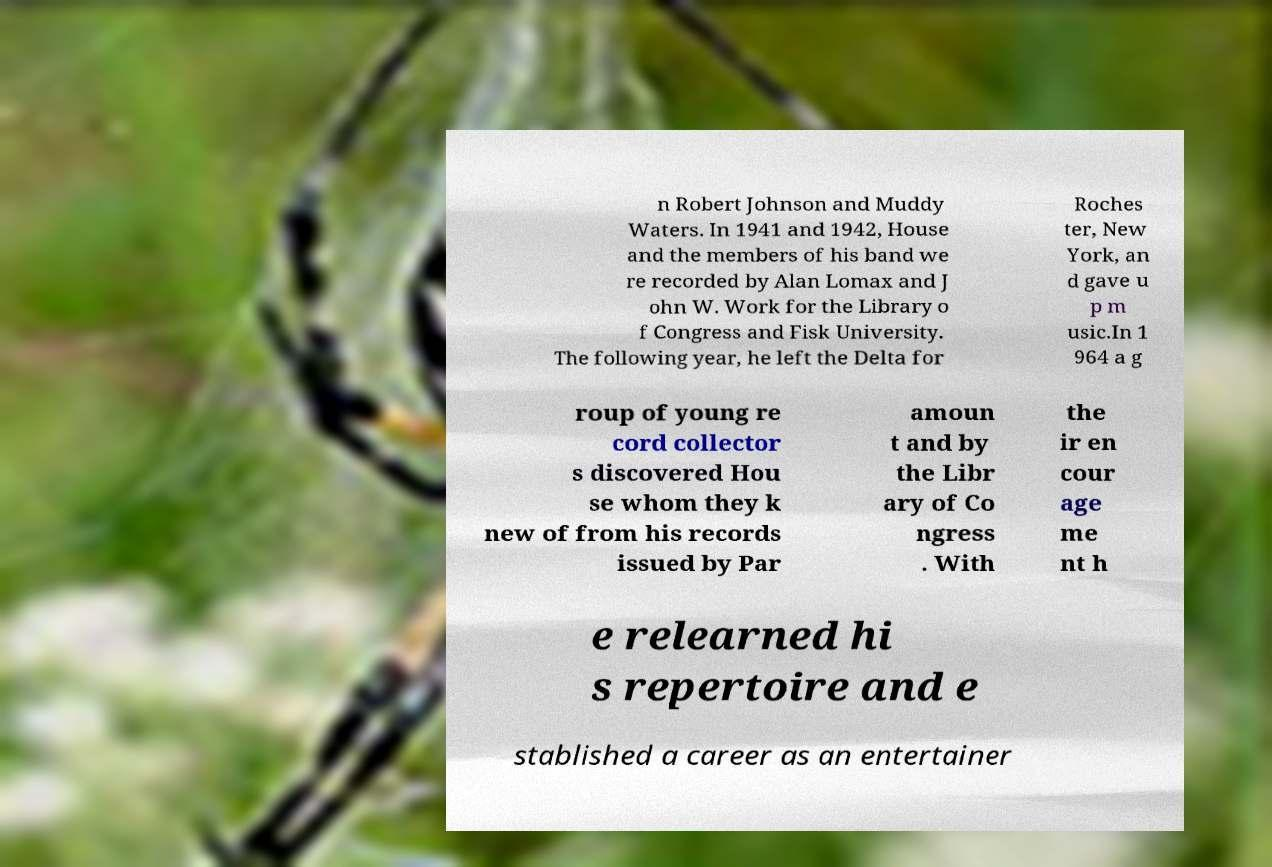Please read and relay the text visible in this image. What does it say? n Robert Johnson and Muddy Waters. In 1941 and 1942, House and the members of his band we re recorded by Alan Lomax and J ohn W. Work for the Library o f Congress and Fisk University. The following year, he left the Delta for Roches ter, New York, an d gave u p m usic.In 1 964 a g roup of young re cord collector s discovered Hou se whom they k new of from his records issued by Par amoun t and by the Libr ary of Co ngress . With the ir en cour age me nt h e relearned hi s repertoire and e stablished a career as an entertainer 